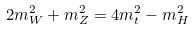<formula> <loc_0><loc_0><loc_500><loc_500>2 m ^ { 2 } _ { W } + m ^ { 2 } _ { Z } = 4 m _ { t } ^ { 2 } - m ^ { 2 } _ { H }</formula> 